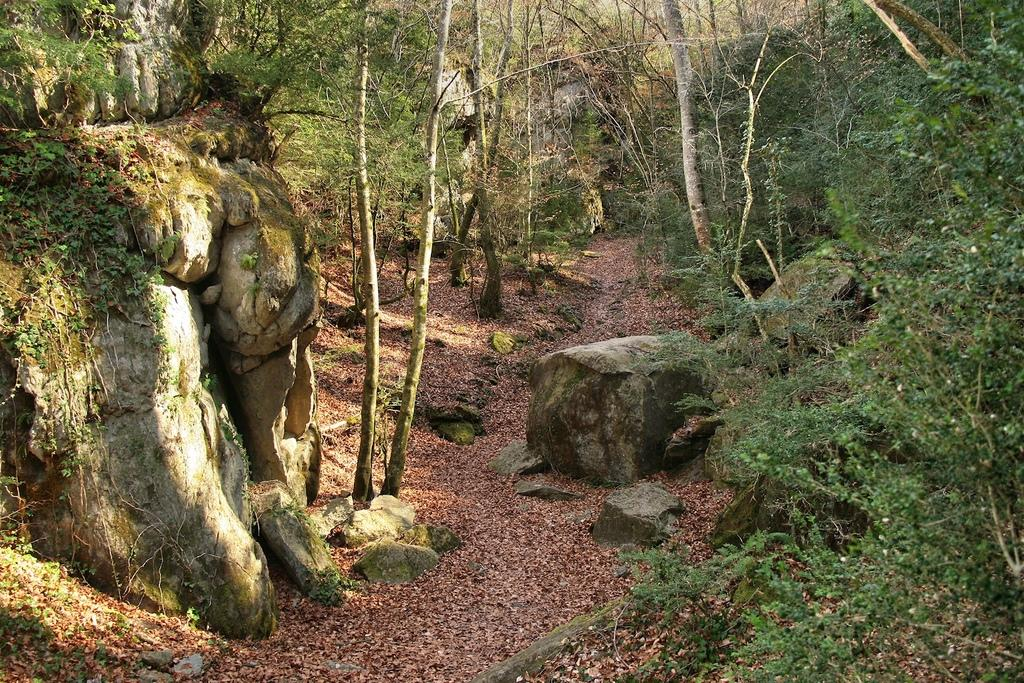What type of vegetation can be seen in the image? There are trees in the image. What can be found on the left side of the image? There are rocks on the left side of the image. What is present on the ground in the image? Leaves are present on the ground in the image. What type of rice is being cooked in the image? There is no rice present in the image; it features trees, rocks, and leaves on the ground. What flag is being raised in the image? There is no flag present in the image. 